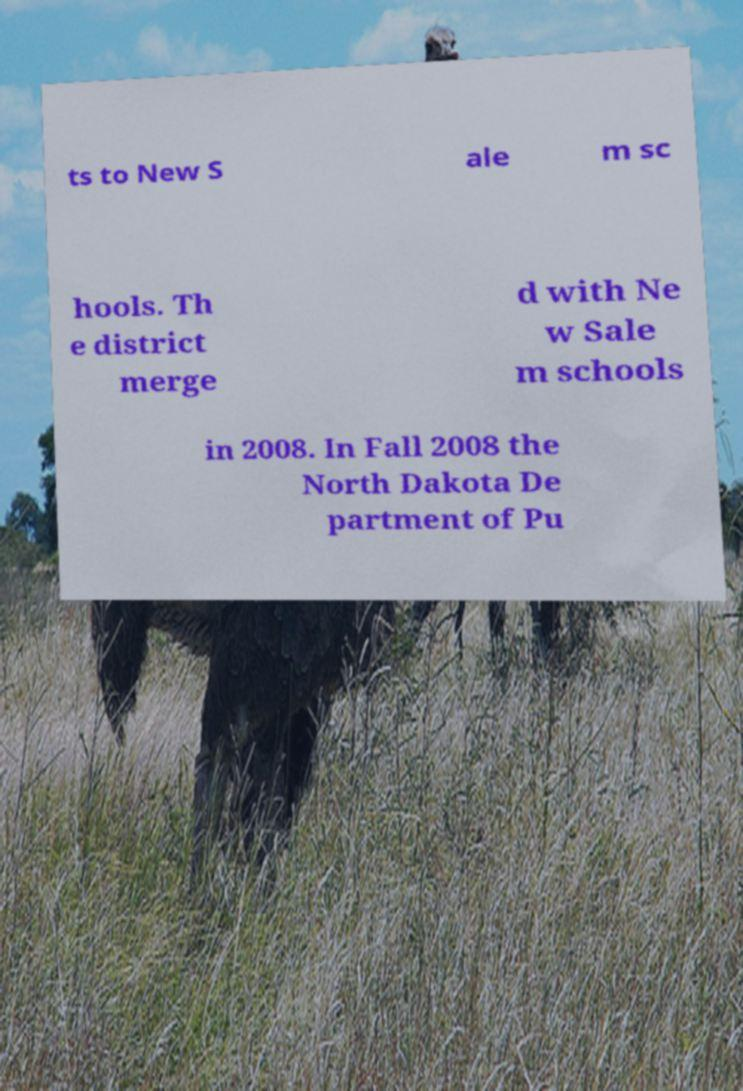Please read and relay the text visible in this image. What does it say? ts to New S ale m sc hools. Th e district merge d with Ne w Sale m schools in 2008. In Fall 2008 the North Dakota De partment of Pu 